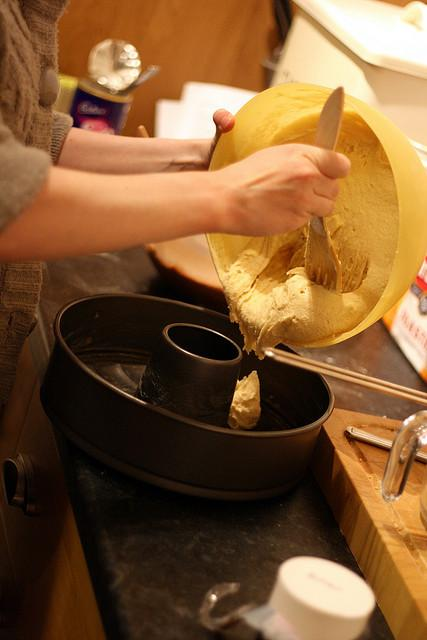What is being poured here? cake batter 